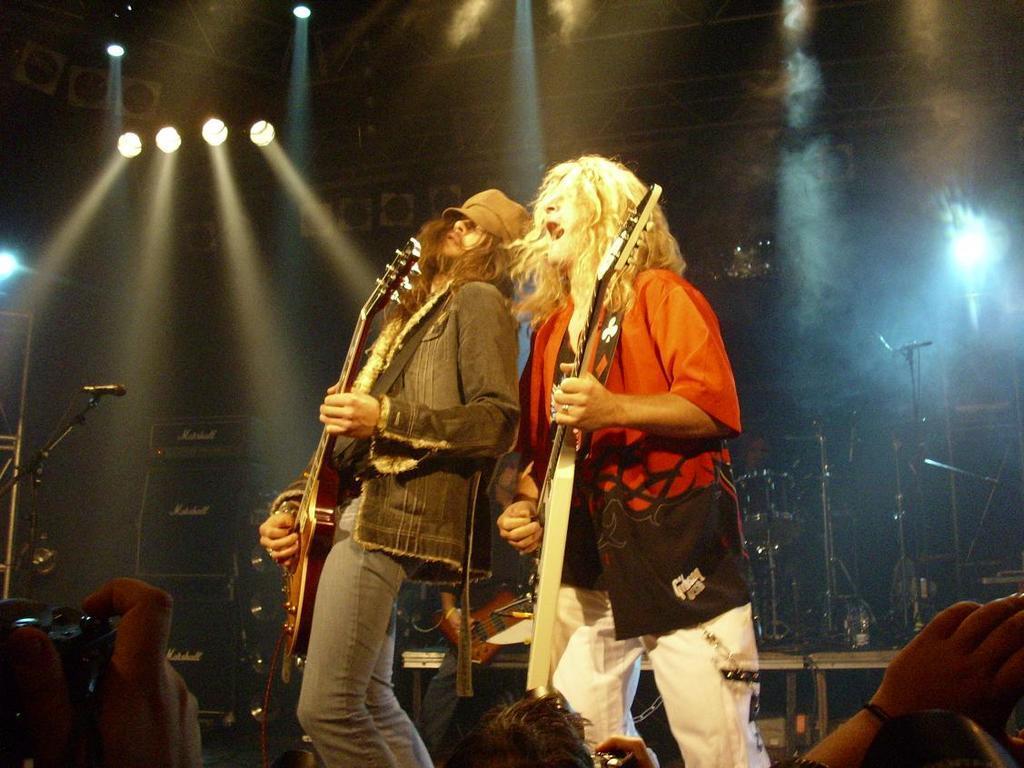Can you describe this image briefly? On the background we can see lights, drums and mike's. Here we can see two persons playing guitar and singing. We can see a person's hand holding a camera. 